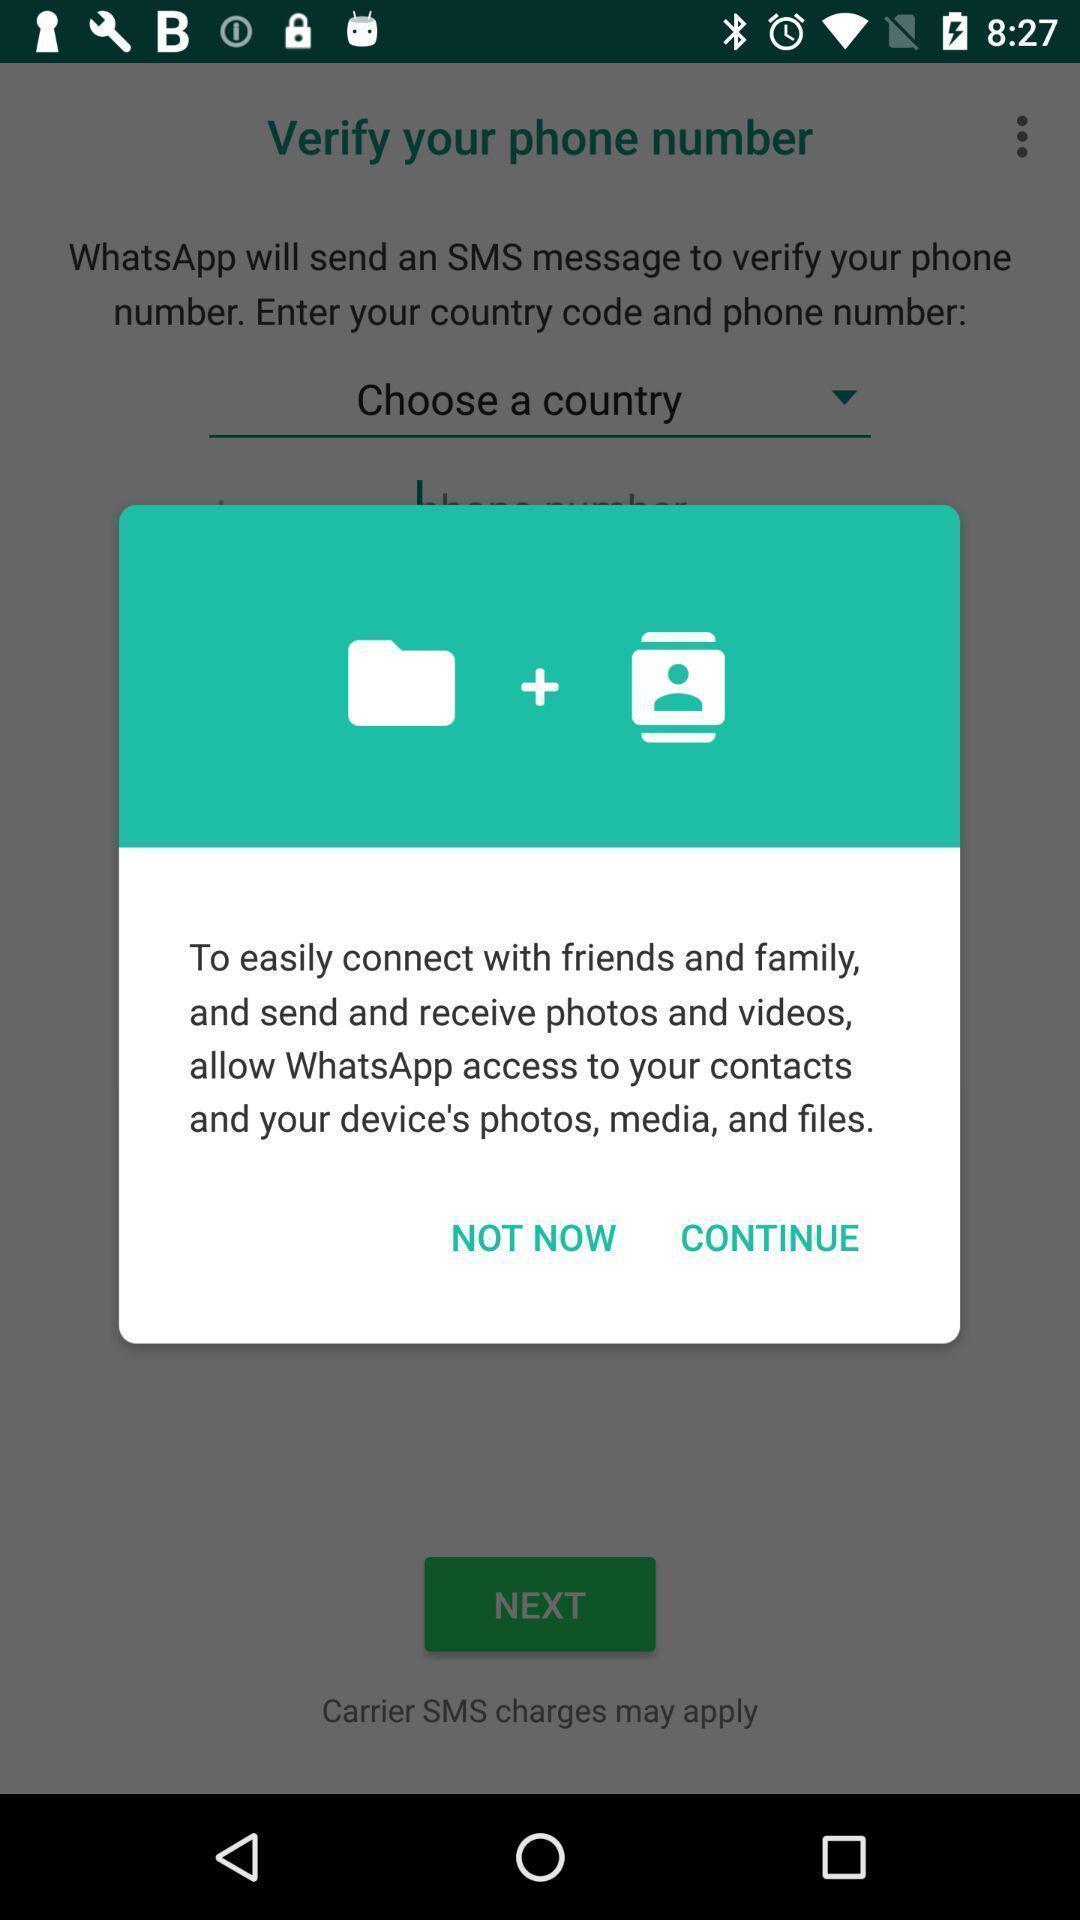Provide a detailed account of this screenshot. Pop-up shows an option to continue. 